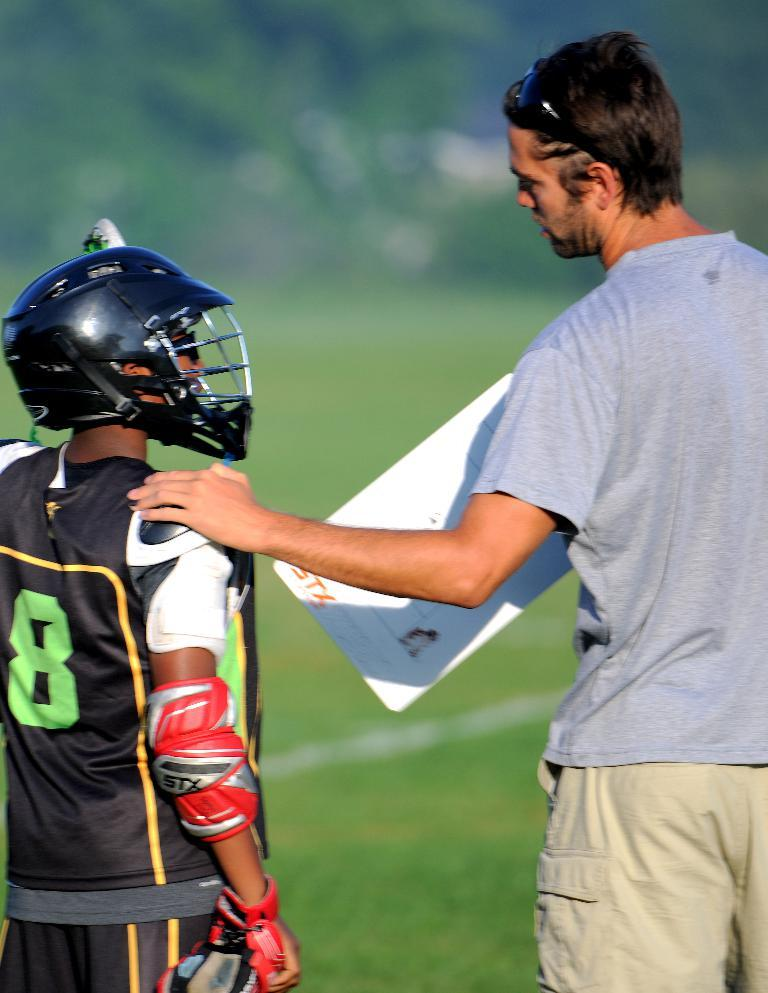What is the person in the image wearing? The person in the image is wearing a black t-shirt and helmet. What is the person holding in the image? The person is holding a board in the image. What type of vegetation can be seen in the background of the image? Trees are visible in the background of the image. What type of ground surface is visible at the bottom of the image? Grass is visible at the bottom of the image. What riddle is the stranger telling in the image? There is no stranger present in the image, nor is there any indication of a riddle being told. 